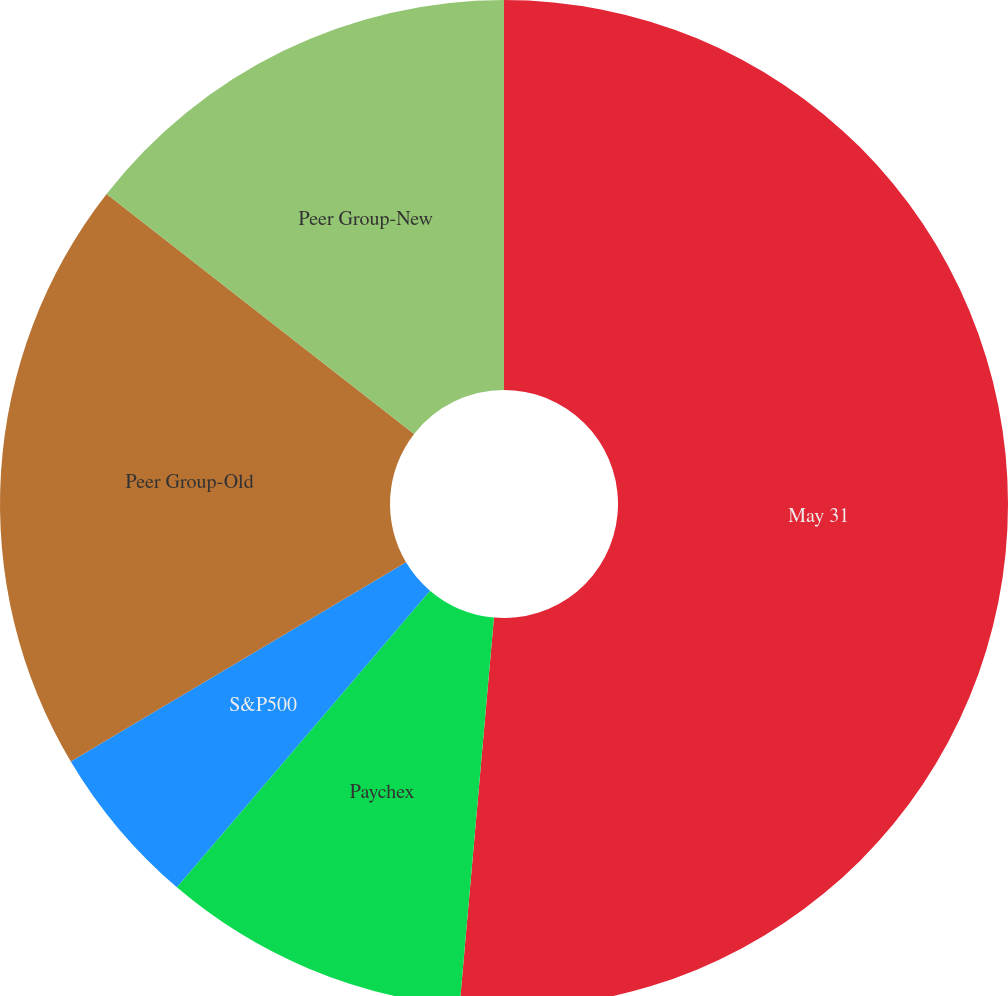Convert chart to OTSL. <chart><loc_0><loc_0><loc_500><loc_500><pie_chart><fcel>May 31<fcel>Paychex<fcel>S&P500<fcel>Peer Group-Old<fcel>Peer Group-New<nl><fcel>51.41%<fcel>9.84%<fcel>5.22%<fcel>19.08%<fcel>14.46%<nl></chart> 